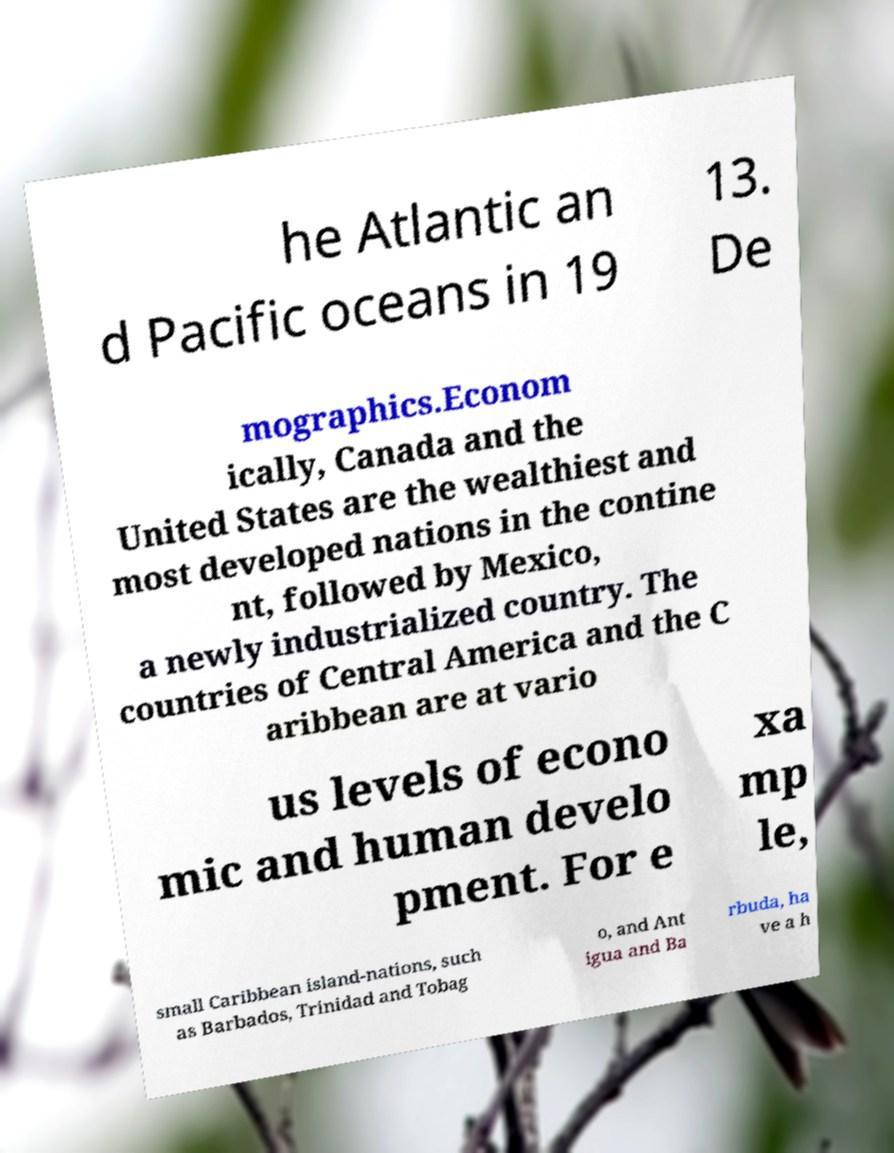For documentation purposes, I need the text within this image transcribed. Could you provide that? he Atlantic an d Pacific oceans in 19 13. De mographics.Econom ically, Canada and the United States are the wealthiest and most developed nations in the contine nt, followed by Mexico, a newly industrialized country. The countries of Central America and the C aribbean are at vario us levels of econo mic and human develo pment. For e xa mp le, small Caribbean island-nations, such as Barbados, Trinidad and Tobag o, and Ant igua and Ba rbuda, ha ve a h 